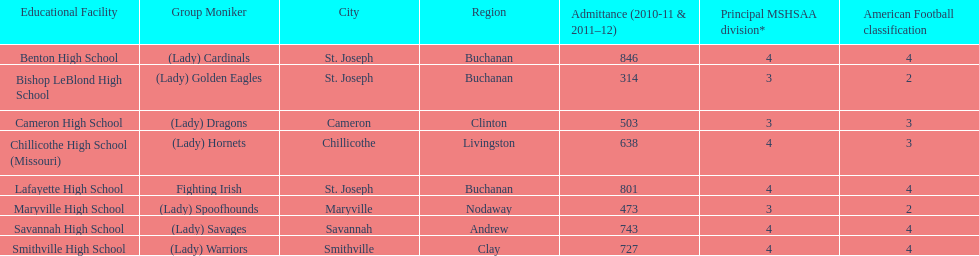Benton high school and bishop leblond high school are both located in what town? St. Joseph. 